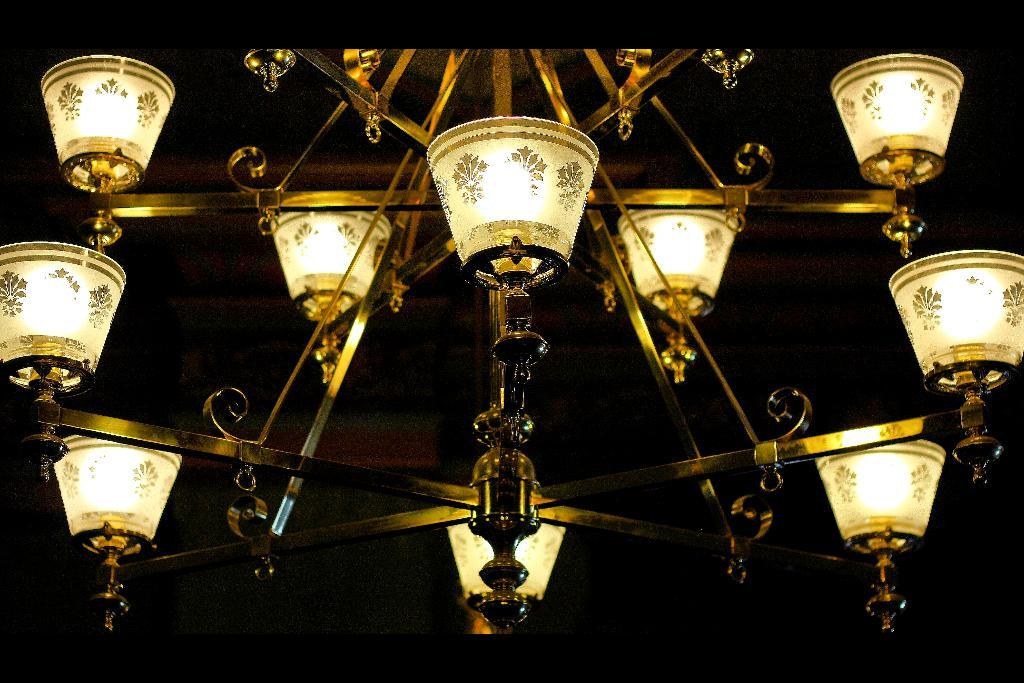What type of light fixture is visible in the image? There is a chandelier light in the image. How would you describe the overall lighting in the image? The background of the image is dark. What type of lace can be seen on the skin of the person in the image? There is no person present in the image, and therefore no lace or skin can be observed. 